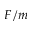<formula> <loc_0><loc_0><loc_500><loc_500>F / m</formula> 